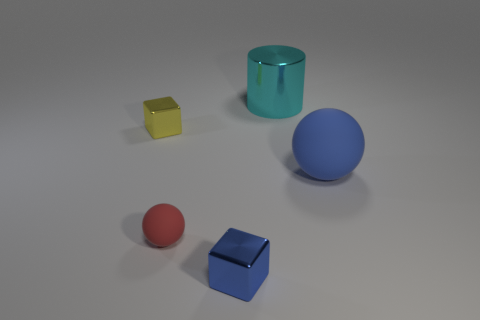Is the shape of the blue rubber object the same as the rubber thing left of the blue metallic thing?
Keep it short and to the point. Yes. There is a red thing that is in front of the matte thing that is right of the large cyan object; how many metal cubes are to the left of it?
Ensure brevity in your answer.  1. There is another small thing that is the same shape as the blue shiny thing; what is its color?
Your answer should be very brief. Yellow. Is there anything else that is the same shape as the cyan object?
Your answer should be compact. No. How many cylinders are either cyan objects or large blue rubber objects?
Give a very brief answer. 1. What shape is the cyan metal thing?
Provide a short and direct response. Cylinder. There is a yellow cube; are there any objects in front of it?
Your response must be concise. Yes. Does the small blue thing have the same material as the blue object behind the tiny blue shiny cube?
Keep it short and to the point. No. There is a rubber thing on the left side of the small blue metallic cube; is it the same shape as the big matte object?
Keep it short and to the point. Yes. What number of yellow objects have the same material as the large sphere?
Offer a very short reply. 0. 